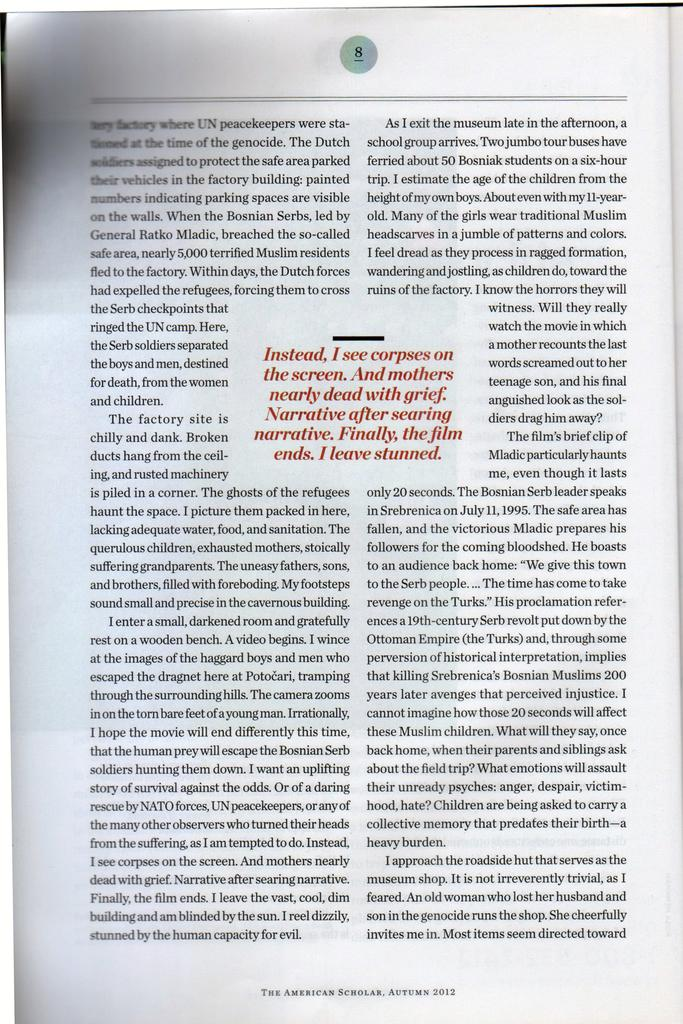<image>
Create a compact narrative representing the image presented. A book is lying open to page 8. 